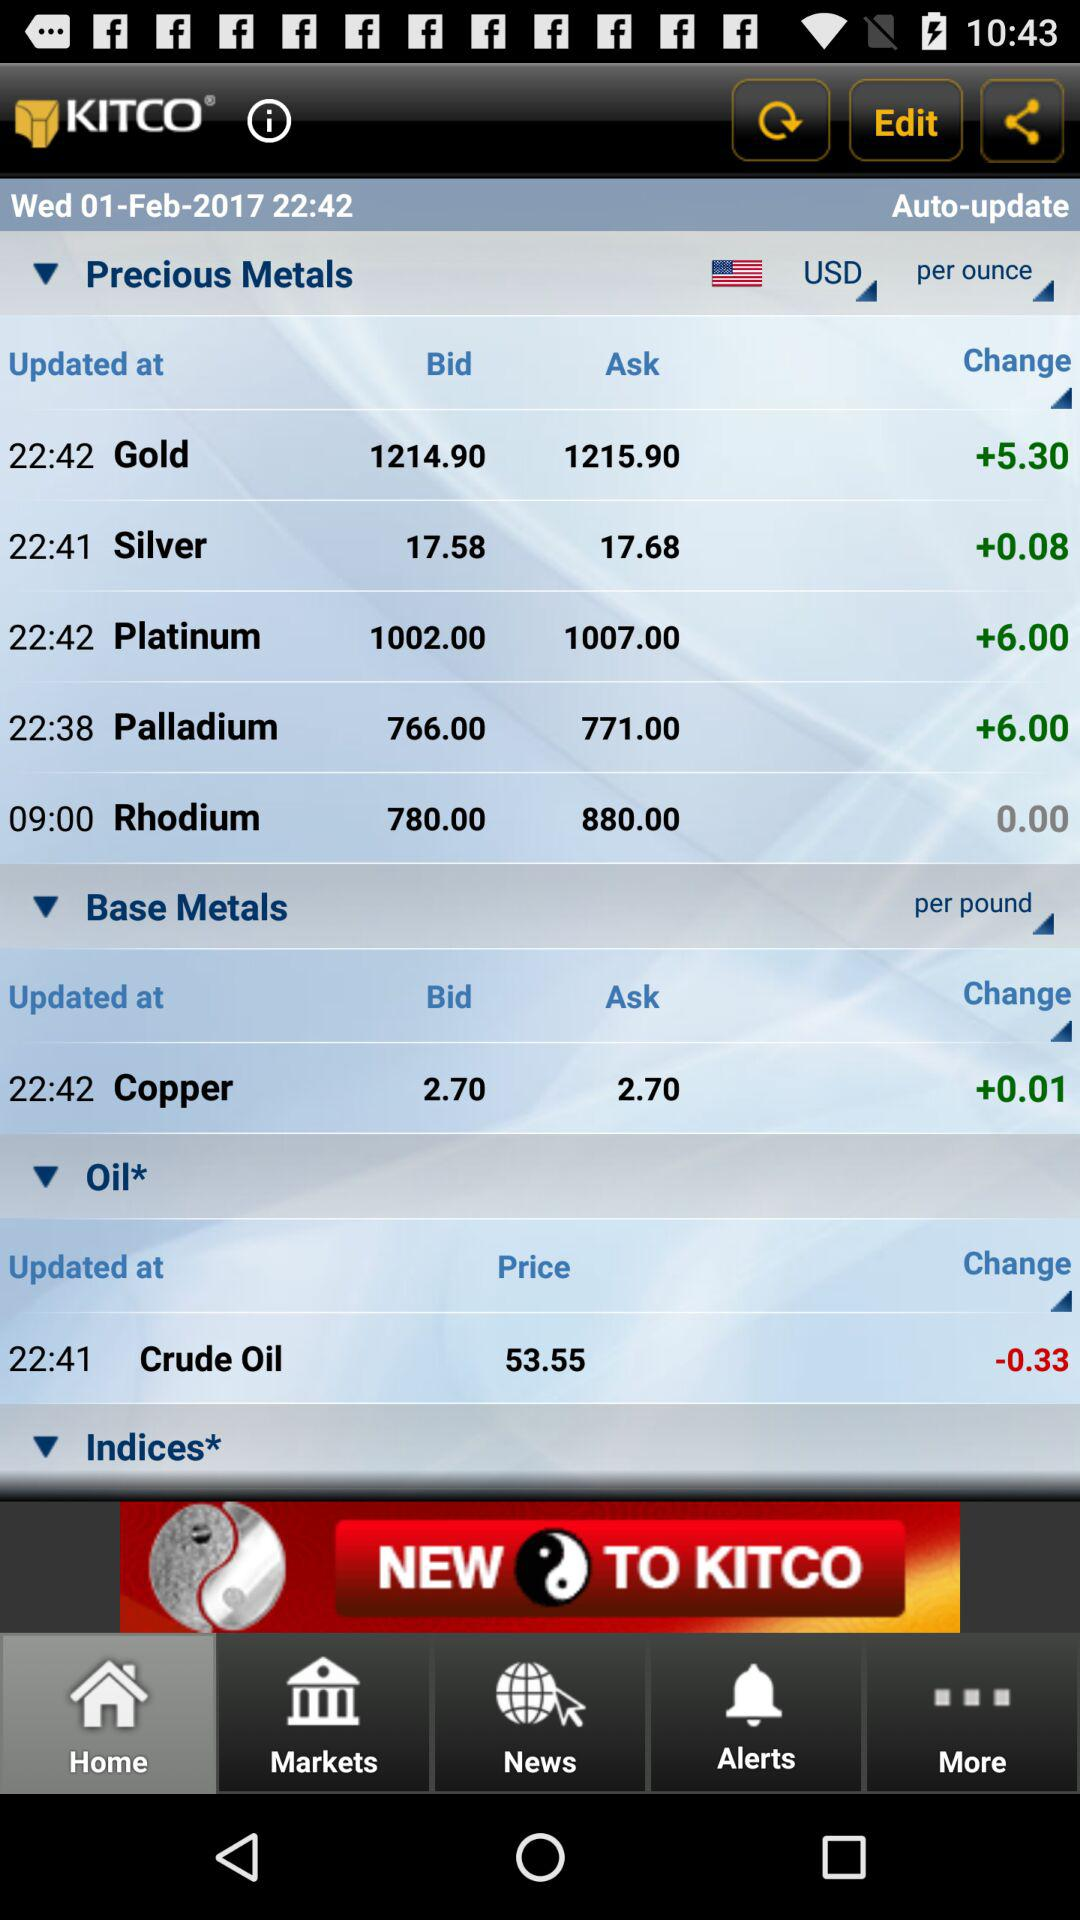When was the price of crude oil updated? The price of crude oil was updated at 22:41. 